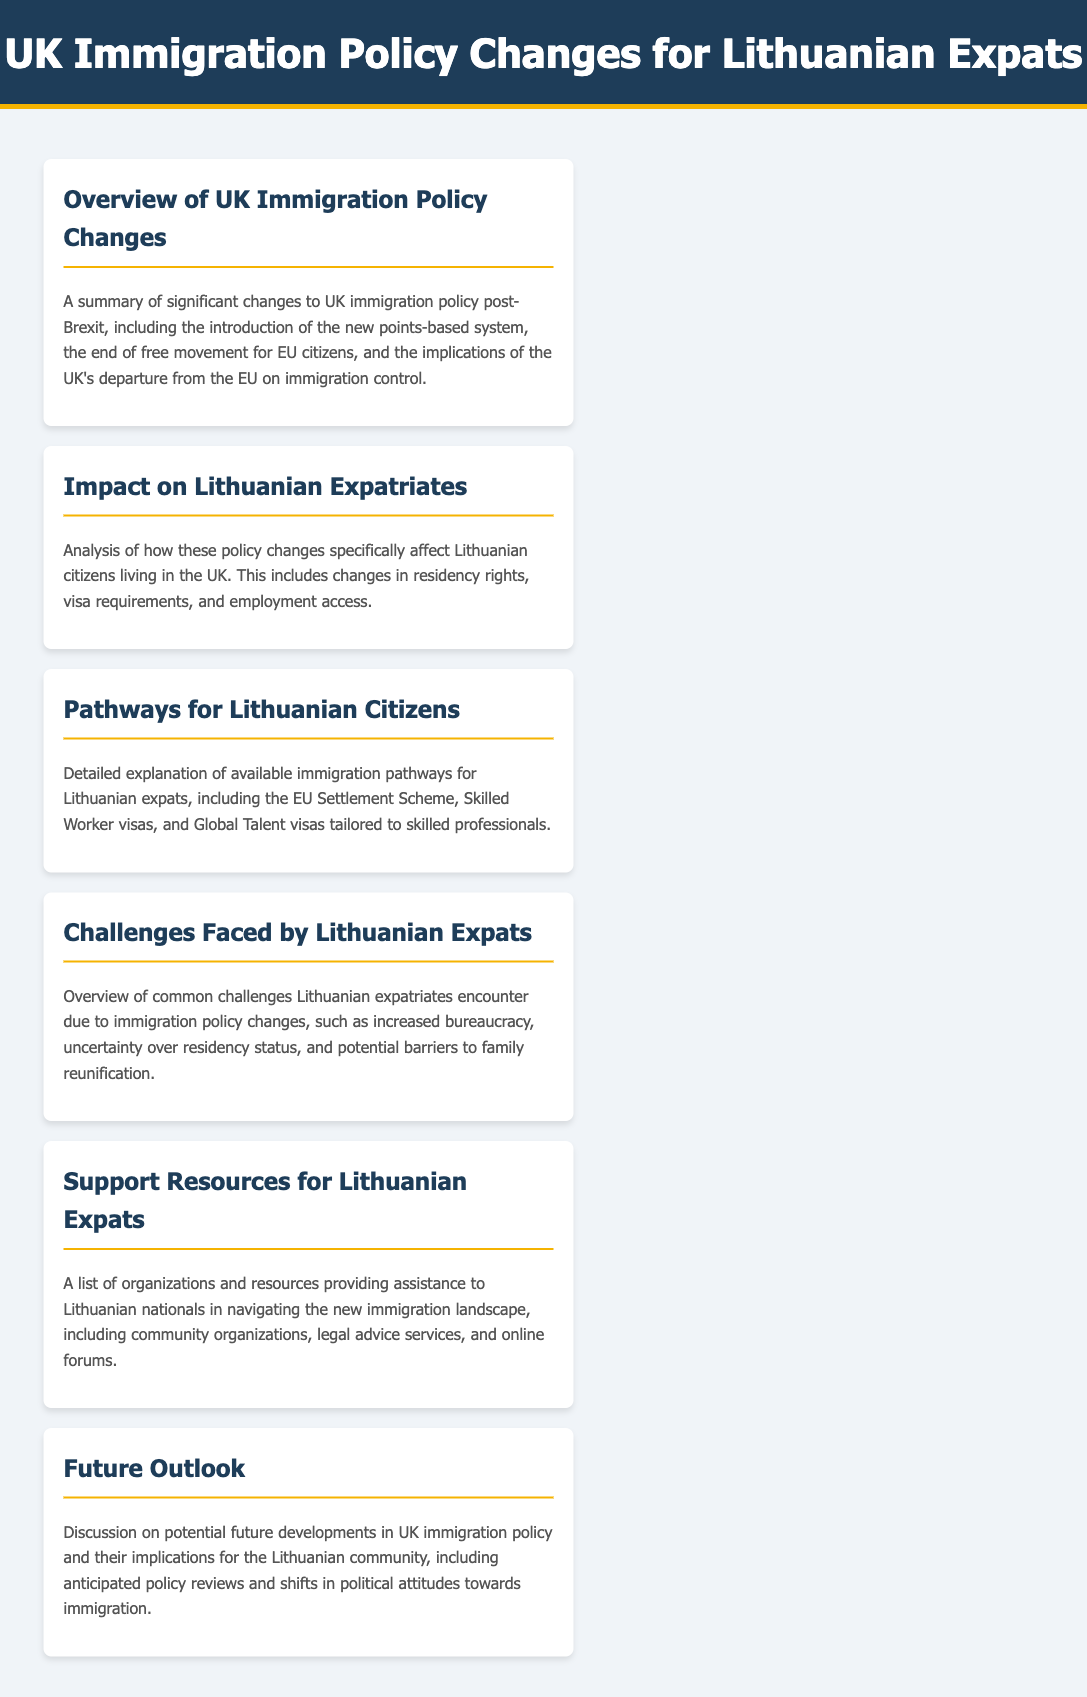What is the title of the document? The title of the document is specified in the HTML head section, which is "UK Immigration Policy Changes for Lithuanian Expats."
Answer: UK Immigration Policy Changes for Lithuanian Expats What system was introduced in the UK immigration policy changes? The new points-based system is mentioned in the overview of policy changes.
Answer: points-based system What is one of the immigration pathways for Lithuanian citizens? The document lists the EU Settlement Scheme, Skilled Worker visas, and Global Talent visas as available pathways.
Answer: EU Settlement Scheme What type of challenges do Lithuanian expatriates face? The document describes common challenges, including increased bureaucracy and uncertainty over residency status.
Answer: increased bureaucracy Which section discusses support resources for Lithuanian expats? The "Support Resources for Lithuanian Expats" section specifically addresses assistance available to Lithuanian nationals.
Answer: Support Resources for Lithuanian Expats What significant change occurred regarding residency rights? The change refers to the end of free movement for EU citizens, which impacts residency rights.
Answer: end of free movement What is a concern mentioned for family reunification? Potential barriers to family reunification are noted as a concern for Lithuanian expatriates.
Answer: potential barriers What aspect of future policy is discussed? The document discusses anticipated policy reviews and shifts in political attitudes towards immigration.
Answer: anticipated policy reviews 